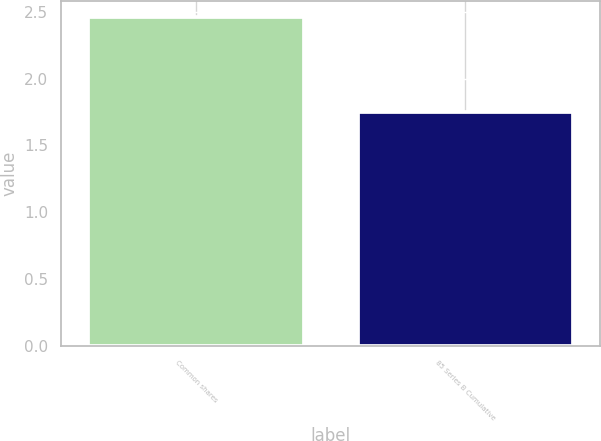Convert chart to OTSL. <chart><loc_0><loc_0><loc_500><loc_500><bar_chart><fcel>Common shares<fcel>85 Series B Cumulative<nl><fcel>2.46<fcel>1.75<nl></chart> 